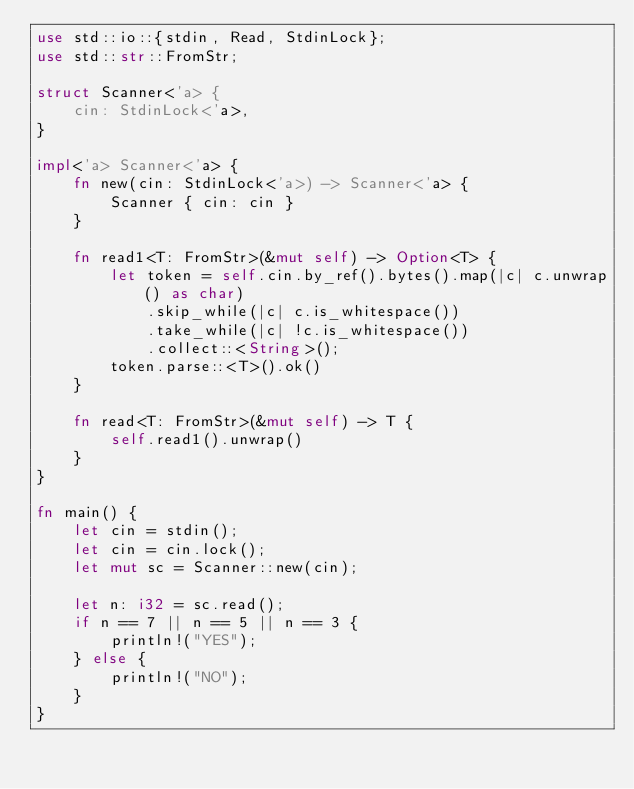Convert code to text. <code><loc_0><loc_0><loc_500><loc_500><_Rust_>use std::io::{stdin, Read, StdinLock};
use std::str::FromStr;

struct Scanner<'a> {
    cin: StdinLock<'a>,
}

impl<'a> Scanner<'a> {
    fn new(cin: StdinLock<'a>) -> Scanner<'a> {
        Scanner { cin: cin }
    }

    fn read1<T: FromStr>(&mut self) -> Option<T> {
        let token = self.cin.by_ref().bytes().map(|c| c.unwrap() as char)
            .skip_while(|c| c.is_whitespace())
            .take_while(|c| !c.is_whitespace())
            .collect::<String>();
        token.parse::<T>().ok()
    }

    fn read<T: FromStr>(&mut self) -> T {
        self.read1().unwrap()
    }
}

fn main() {
    let cin = stdin();
    let cin = cin.lock();
    let mut sc = Scanner::new(cin);

    let n: i32 = sc.read();
    if n == 7 || n == 5 || n == 3 {
        println!("YES");
    } else {
        println!("NO");
    }
}
</code> 